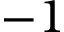Convert formula to latex. <formula><loc_0><loc_0><loc_500><loc_500>- 1</formula> 